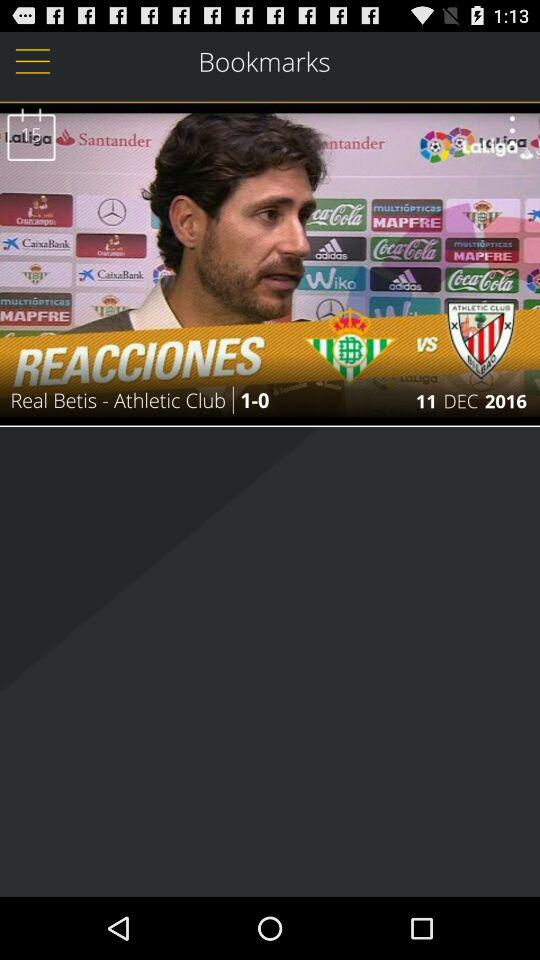When is the next "Real Betis" match?
When the provided information is insufficient, respond with <no answer>. <no answer> 